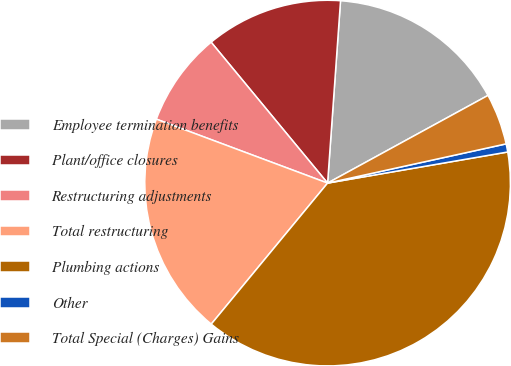Convert chart to OTSL. <chart><loc_0><loc_0><loc_500><loc_500><pie_chart><fcel>Employee termination benefits<fcel>Plant/office closures<fcel>Restructuring adjustments<fcel>Total restructuring<fcel>Plumbing actions<fcel>Other<fcel>Total Special (Charges) Gains<nl><fcel>15.91%<fcel>12.12%<fcel>8.32%<fcel>19.71%<fcel>38.7%<fcel>0.72%<fcel>4.52%<nl></chart> 